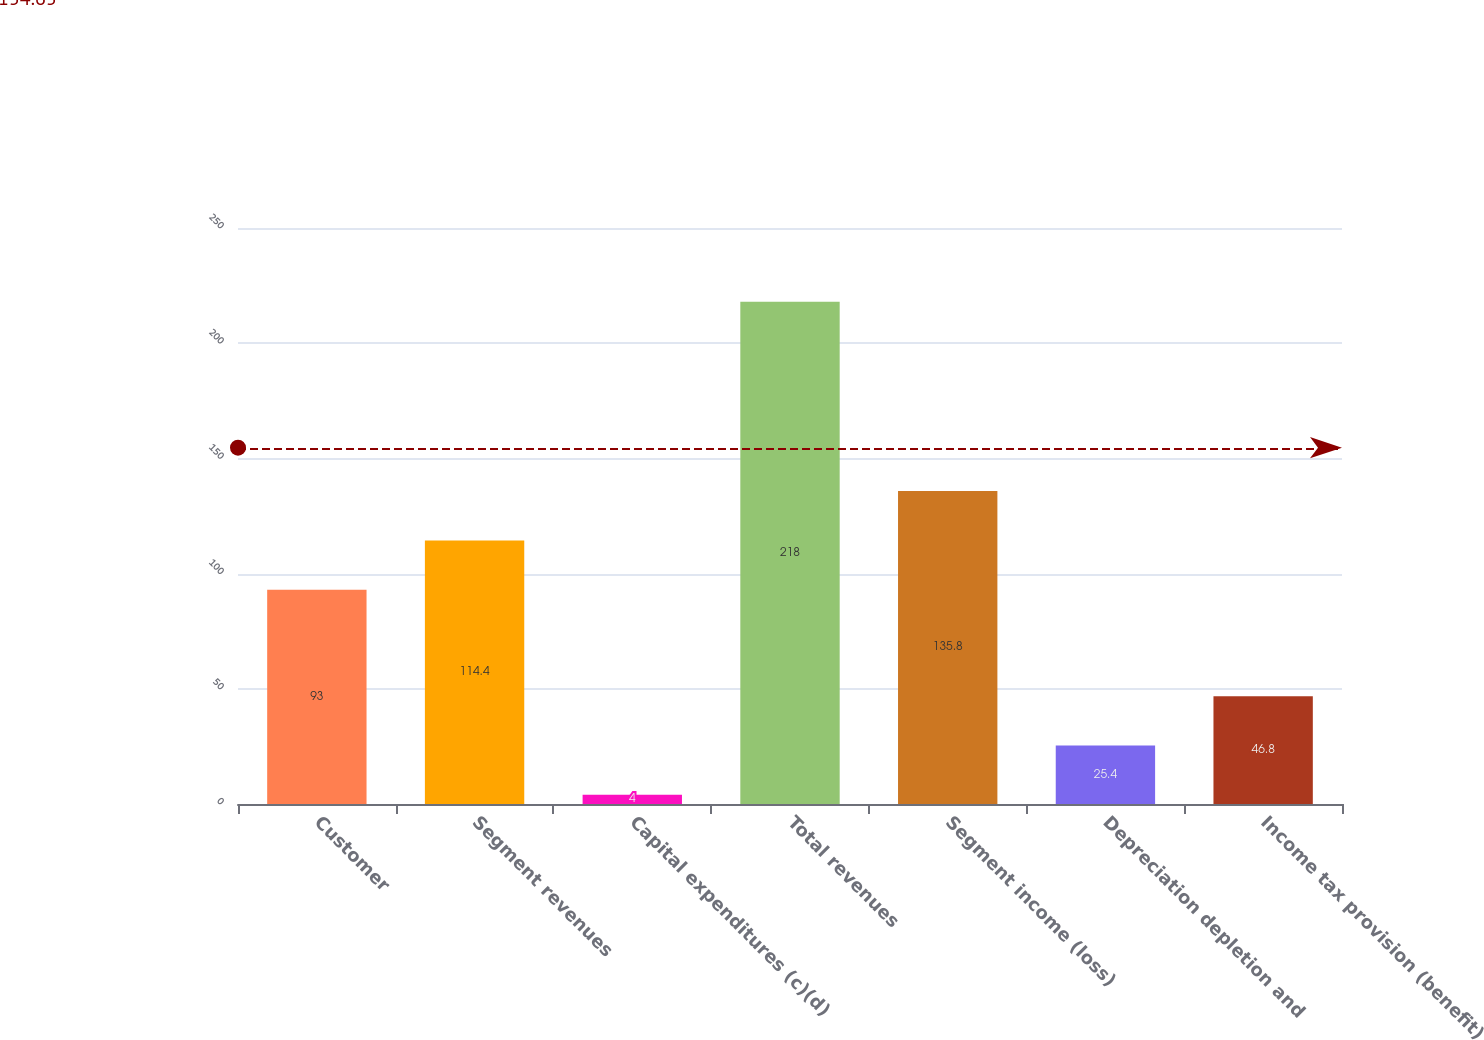<chart> <loc_0><loc_0><loc_500><loc_500><bar_chart><fcel>Customer<fcel>Segment revenues<fcel>Capital expenditures (c)(d)<fcel>Total revenues<fcel>Segment income (loss)<fcel>Depreciation depletion and<fcel>Income tax provision (benefit)<nl><fcel>93<fcel>114.4<fcel>4<fcel>218<fcel>135.8<fcel>25.4<fcel>46.8<nl></chart> 